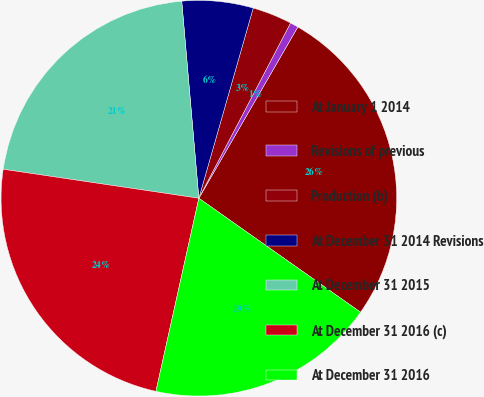Convert chart. <chart><loc_0><loc_0><loc_500><loc_500><pie_chart><fcel>At January 1 2014<fcel>Revisions of previous<fcel>Production (b)<fcel>At December 31 2014 Revisions<fcel>At December 31 2015<fcel>At December 31 2016 (c)<fcel>At December 31 2016<nl><fcel>26.43%<fcel>0.67%<fcel>3.24%<fcel>5.81%<fcel>21.28%<fcel>23.86%<fcel>18.71%<nl></chart> 